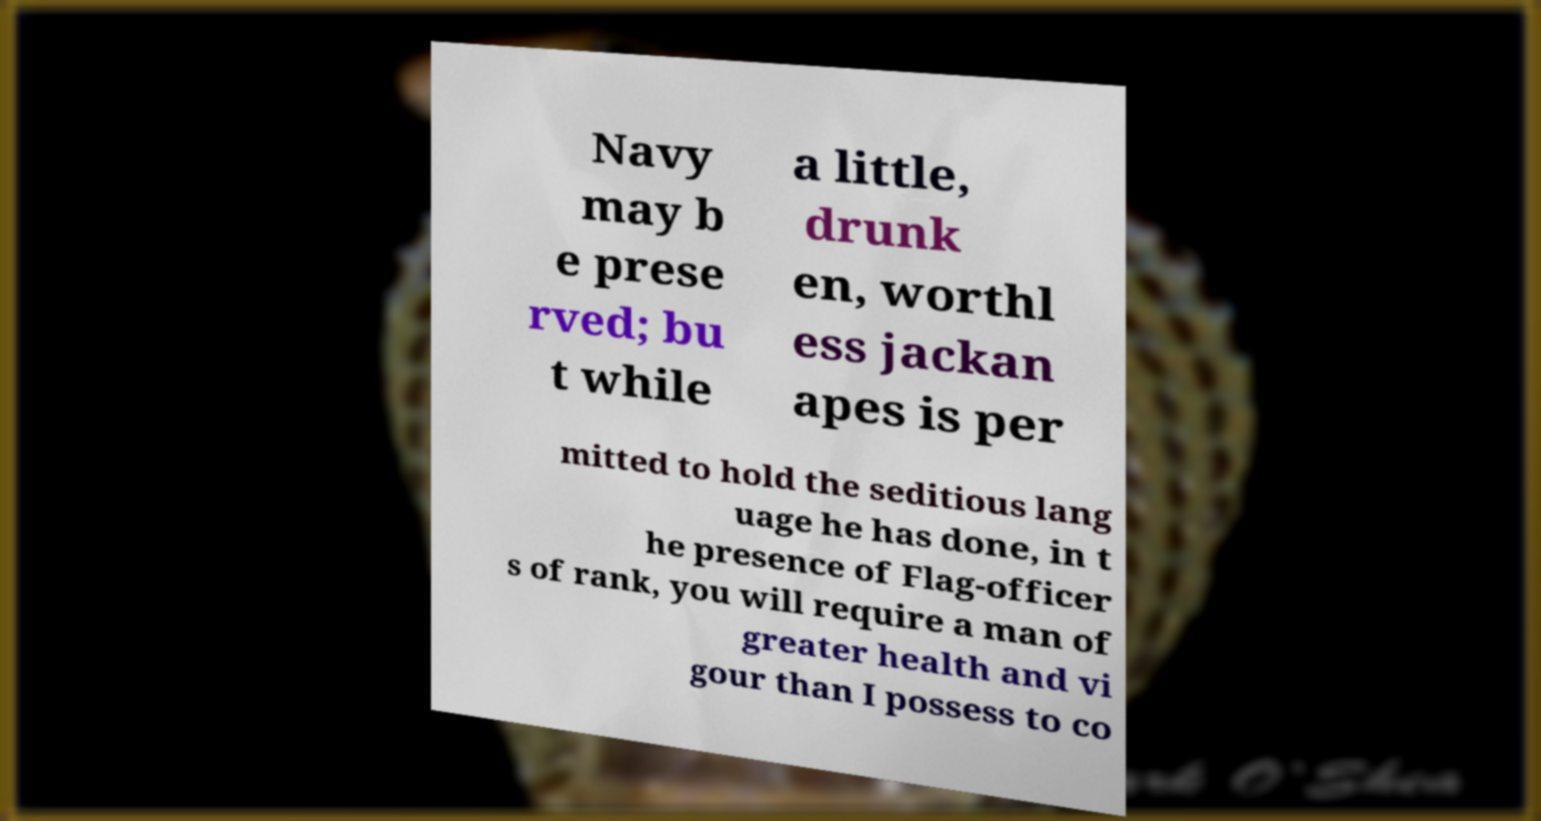I need the written content from this picture converted into text. Can you do that? Navy may b e prese rved; bu t while a little, drunk en, worthl ess jackan apes is per mitted to hold the seditious lang uage he has done, in t he presence of Flag-officer s of rank, you will require a man of greater health and vi gour than I possess to co 